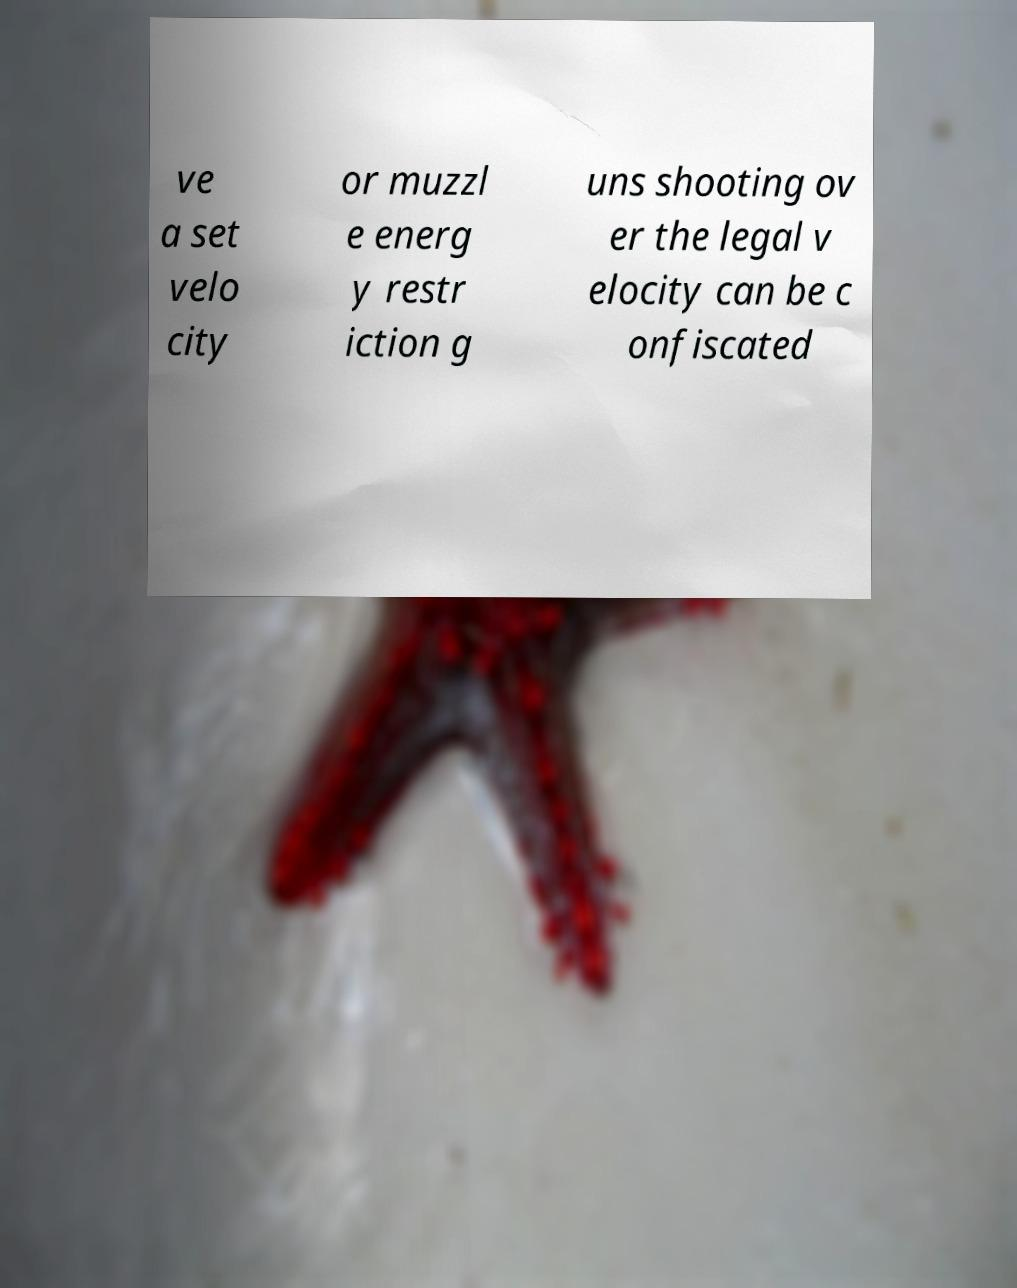Please identify and transcribe the text found in this image. ve a set velo city or muzzl e energ y restr iction g uns shooting ov er the legal v elocity can be c onfiscated 